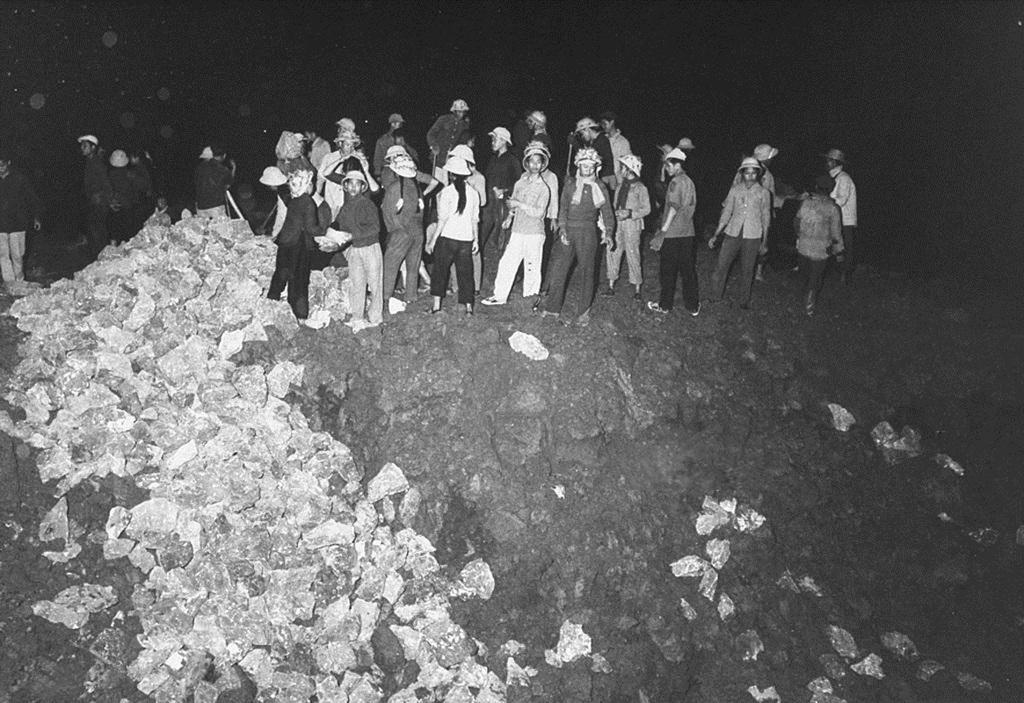Describe this image in one or two sentences. It is a black and white image, there are few people standing on the surface and on the left side it looks like there are some covers and they are collecting those covers. 